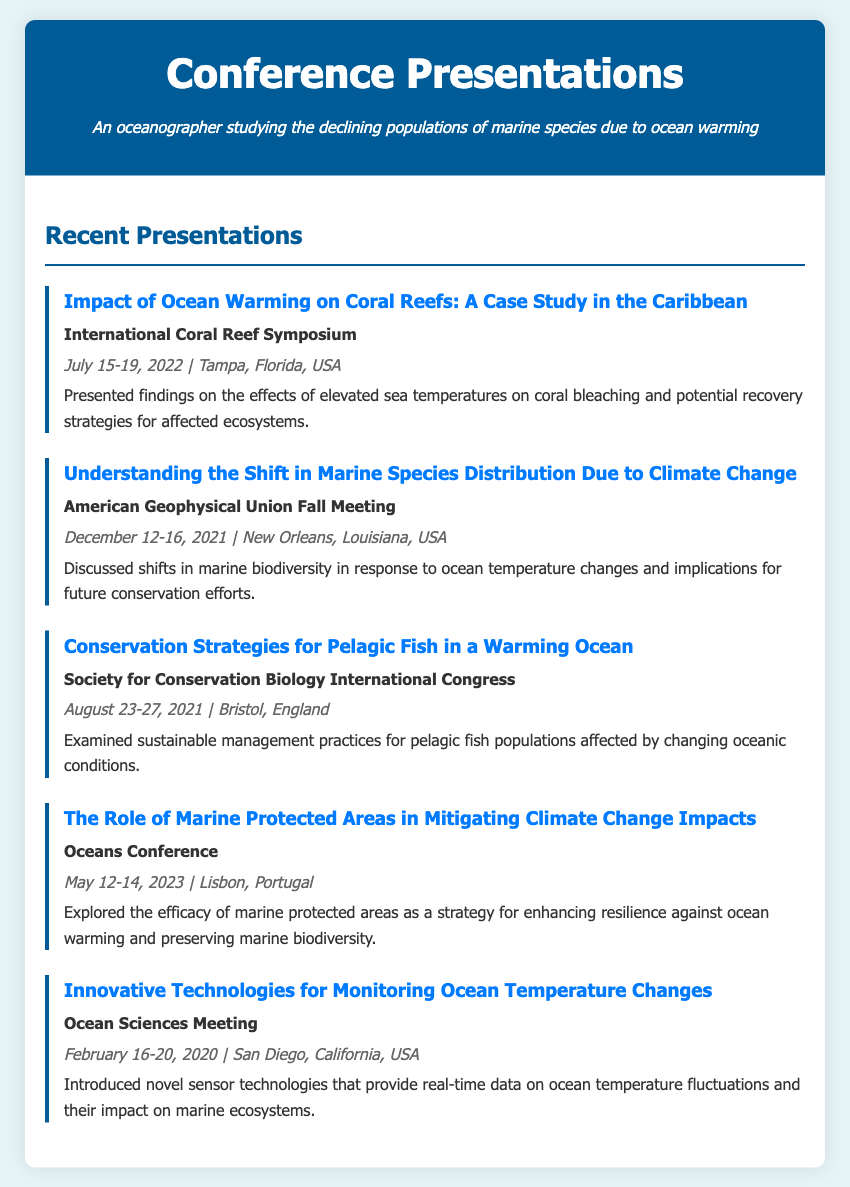What is the title of the presentation given at the International Coral Reef Symposium? The title of the presentation is listed directly under the conference name in the document.
Answer: Impact of Ocean Warming on Coral Reefs: A Case Study in the Caribbean When was the Oceans Conference held? The date of the Oceans Conference is specified in the date-location section for that presentation.
Answer: May 12-14, 2023 Where was the Society for Conservation Biology International Congress held? The location is mentioned in the date-location section for that presentation.
Answer: Bristol, England What marine conservation strategy was discussed in the presentation at the Oceans Conference? The document specifies the topic discussed regarding marine protected areas and their role against climate change.
Answer: Enhancing resilience against ocean warming Which presentation discussed innovative technologies? The document lists the titles of presentations which include information about the technologies being discussed.
Answer: Innovative Technologies for Monitoring Ocean Temperature Changes How many presentations are listed in total? The total number of presentations can be counted from the "Recent Presentations" section of the document.
Answer: Five What was the main focus of the presentation at the American Geophysical Union Fall Meeting? The description of the presentation indicates the shift in marine species due to climate change.
Answer: Shifts in marine biodiversity Who presented the findings on coral bleaching? The author of the presentation is not explicitly named in the document, which is typical for this type of document.
Answer: Not provided 